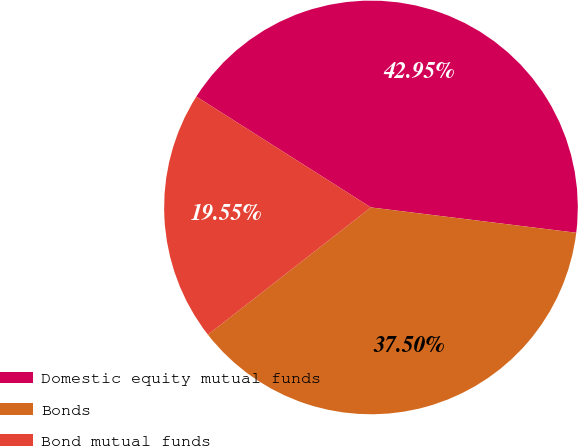Convert chart. <chart><loc_0><loc_0><loc_500><loc_500><pie_chart><fcel>Domestic equity mutual funds<fcel>Bonds<fcel>Bond mutual funds<nl><fcel>42.95%<fcel>37.5%<fcel>19.55%<nl></chart> 